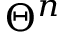Convert formula to latex. <formula><loc_0><loc_0><loc_500><loc_500>\Theta ^ { n }</formula> 